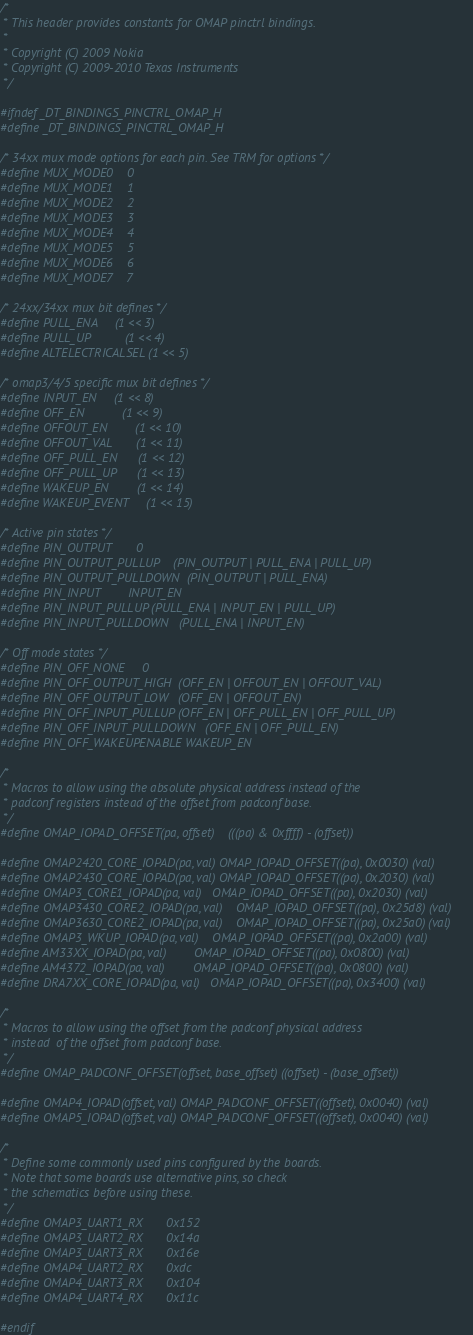Convert code to text. <code><loc_0><loc_0><loc_500><loc_500><_C_>/*
 * This header provides constants for OMAP pinctrl bindings.
 *
 * Copyright (C) 2009 Nokia
 * Copyright (C) 2009-2010 Texas Instruments
 */

#ifndef _DT_BINDINGS_PINCTRL_OMAP_H
#define _DT_BINDINGS_PINCTRL_OMAP_H

/* 34xx mux mode options for each pin. See TRM for options */
#define MUX_MODE0	0
#define MUX_MODE1	1
#define MUX_MODE2	2
#define MUX_MODE3	3
#define MUX_MODE4	4
#define MUX_MODE5	5
#define MUX_MODE6	6
#define MUX_MODE7	7

/* 24xx/34xx mux bit defines */
#define PULL_ENA		(1 << 3)
#define PULL_UP			(1 << 4)
#define ALTELECTRICALSEL	(1 << 5)

/* omap3/4/5 specific mux bit defines */
#define INPUT_EN		(1 << 8)
#define OFF_EN			(1 << 9)
#define OFFOUT_EN		(1 << 10)
#define OFFOUT_VAL		(1 << 11)
#define OFF_PULL_EN		(1 << 12)
#define OFF_PULL_UP		(1 << 13)
#define WAKEUP_EN		(1 << 14)
#define WAKEUP_EVENT		(1 << 15)

/* Active pin states */
#define PIN_OUTPUT		0
#define PIN_OUTPUT_PULLUP	(PIN_OUTPUT | PULL_ENA | PULL_UP)
#define PIN_OUTPUT_PULLDOWN	(PIN_OUTPUT | PULL_ENA)
#define PIN_INPUT		INPUT_EN
#define PIN_INPUT_PULLUP	(PULL_ENA | INPUT_EN | PULL_UP)
#define PIN_INPUT_PULLDOWN	(PULL_ENA | INPUT_EN)

/* Off mode states */
#define PIN_OFF_NONE		0
#define PIN_OFF_OUTPUT_HIGH	(OFF_EN | OFFOUT_EN | OFFOUT_VAL)
#define PIN_OFF_OUTPUT_LOW	(OFF_EN | OFFOUT_EN)
#define PIN_OFF_INPUT_PULLUP	(OFF_EN | OFF_PULL_EN | OFF_PULL_UP)
#define PIN_OFF_INPUT_PULLDOWN	(OFF_EN | OFF_PULL_EN)
#define PIN_OFF_WAKEUPENABLE	WAKEUP_EN

/*
 * Macros to allow using the absolute physical address instead of the
 * padconf registers instead of the offset from padconf base.
 */
#define OMAP_IOPAD_OFFSET(pa, offset)	(((pa) & 0xffff) - (offset))

#define OMAP2420_CORE_IOPAD(pa, val)	OMAP_IOPAD_OFFSET((pa), 0x0030) (val)
#define OMAP2430_CORE_IOPAD(pa, val)	OMAP_IOPAD_OFFSET((pa), 0x2030) (val)
#define OMAP3_CORE1_IOPAD(pa, val)	OMAP_IOPAD_OFFSET((pa), 0x2030) (val)
#define OMAP3430_CORE2_IOPAD(pa, val)	OMAP_IOPAD_OFFSET((pa), 0x25d8) (val)
#define OMAP3630_CORE2_IOPAD(pa, val)	OMAP_IOPAD_OFFSET((pa), 0x25a0) (val)
#define OMAP3_WKUP_IOPAD(pa, val)	OMAP_IOPAD_OFFSET((pa), 0x2a00) (val)
#define AM33XX_IOPAD(pa, val)		OMAP_IOPAD_OFFSET((pa), 0x0800) (val)
#define AM4372_IOPAD(pa, val)		OMAP_IOPAD_OFFSET((pa), 0x0800) (val)
#define DRA7XX_CORE_IOPAD(pa, val)	OMAP_IOPAD_OFFSET((pa), 0x3400) (val)

/*
 * Macros to allow using the offset from the padconf physical address
 * instead  of the offset from padconf base.
 */
#define OMAP_PADCONF_OFFSET(offset, base_offset)	((offset) - (base_offset))

#define OMAP4_IOPAD(offset, val)	OMAP_PADCONF_OFFSET((offset), 0x0040) (val)
#define OMAP5_IOPAD(offset, val)	OMAP_PADCONF_OFFSET((offset), 0x0040) (val)

/*
 * Define some commonly used pins configured by the boards.
 * Note that some boards use alternative pins, so check
 * the schematics before using these.
 */
#define OMAP3_UART1_RX		0x152
#define OMAP3_UART2_RX		0x14a
#define OMAP3_UART3_RX		0x16e
#define OMAP4_UART2_RX		0xdc
#define OMAP4_UART3_RX		0x104
#define OMAP4_UART4_RX		0x11c

#endif

</code> 